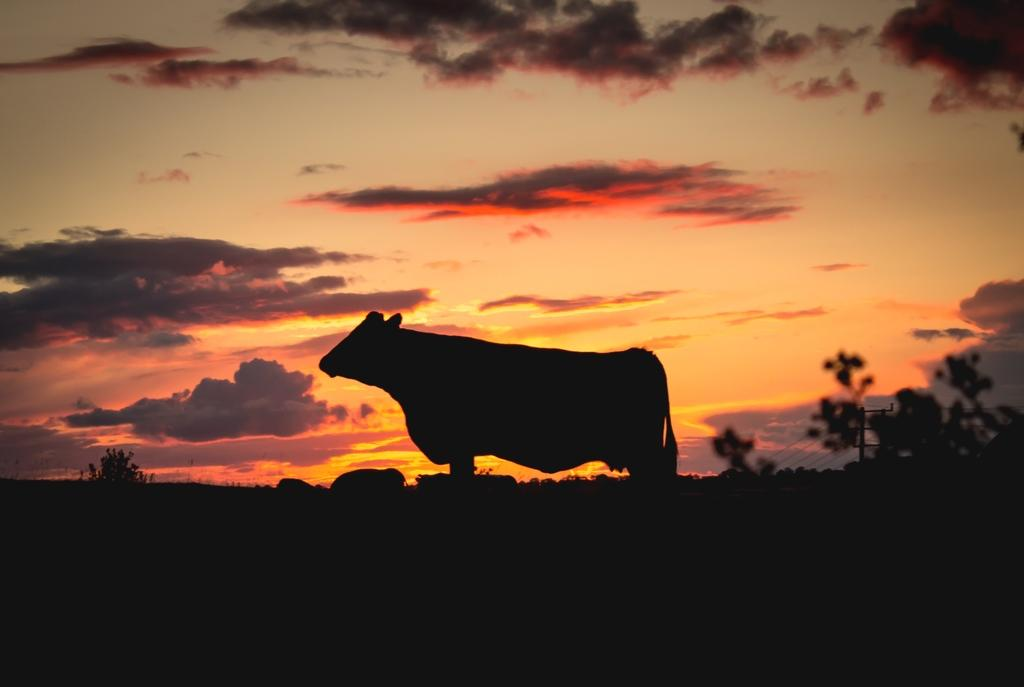What is the main subject in the center of the image? There is a cow in the center of the image. What type of objects can be seen on the ground in the image? There are stones visible in the image. What type of vegetation is present in the image? There are plants in the image. What structures can be seen in the image? There is an utility pole with wires in the image. What is visible in the sky in the image? The sky is visible in the image and appears cloudy. What color is the sweater worn by the cow in the image? There is no sweater present in the image. 